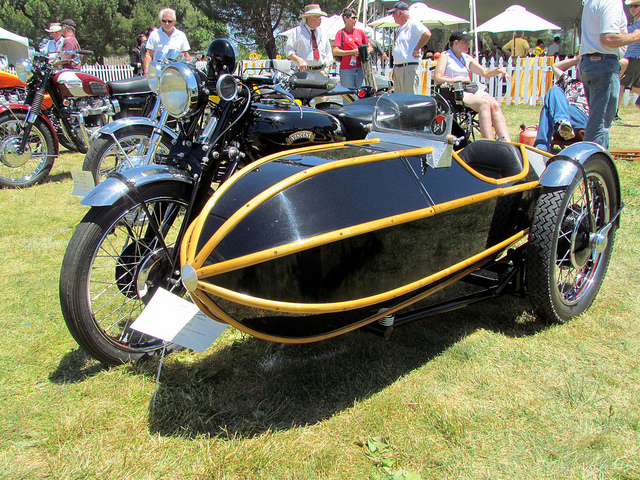<image>What brand is the sidecar? It is unknown the brand of the sidecar. It can be 'flyer', 'honda', 'harley davidson', 'vincent', 'triumph', or 'harley'. What brand is the sidecar? I am not sure what brand is the sidecar. It can be 'flyer', 'honda', 'harley davidson', 'vincent', 'triumph', or 'harley'. 